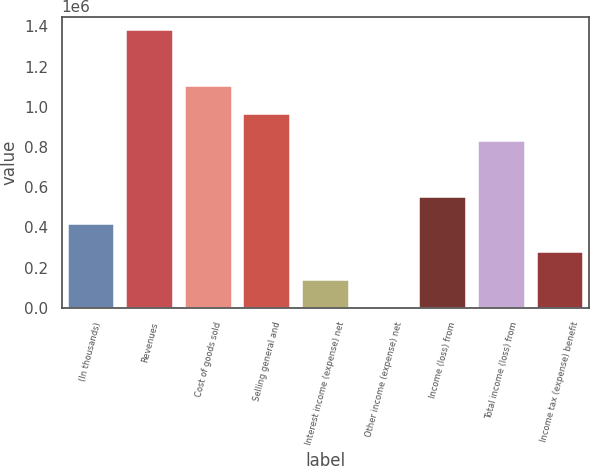<chart> <loc_0><loc_0><loc_500><loc_500><bar_chart><fcel>(In thousands)<fcel>Revenues<fcel>Cost of goods sold<fcel>Selling general and<fcel>Interest income (expense) net<fcel>Other income (expense) net<fcel>Income (loss) from<fcel>Total income (loss) from<fcel>Income tax (expense) benefit<nl><fcel>414544<fcel>1.38035e+06<fcel>1.10441e+06<fcel>966434<fcel>138599<fcel>627<fcel>552517<fcel>828461<fcel>276572<nl></chart> 